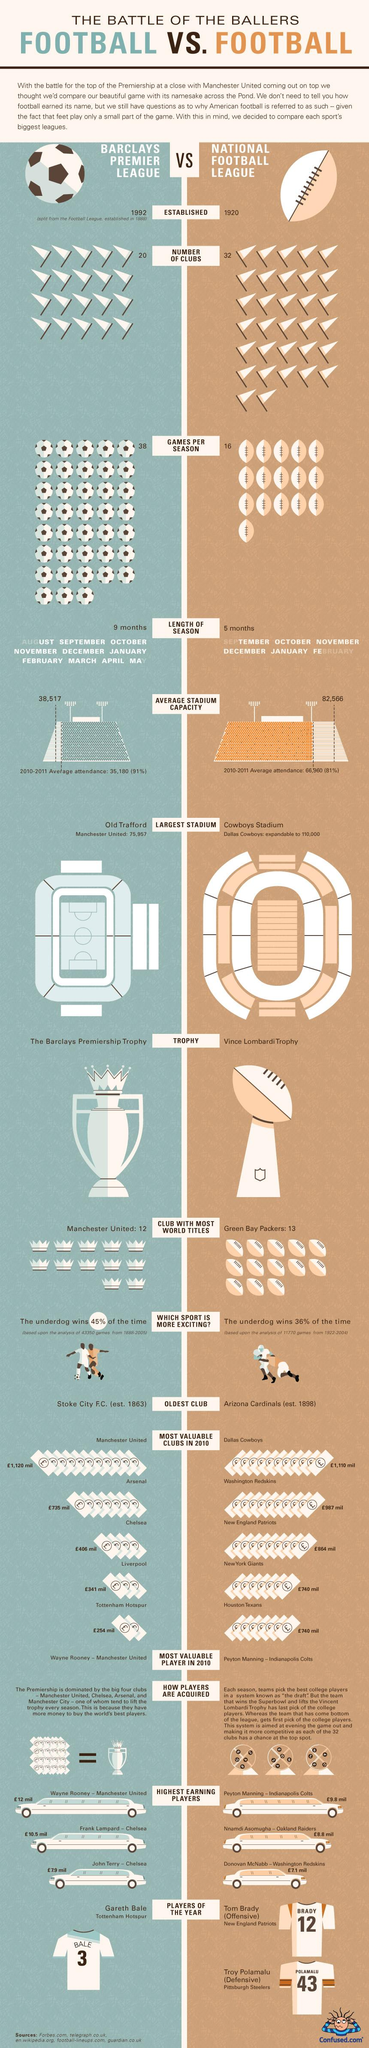Mention a couple of crucial points in this snapshot. Manchester United is the club that has won the most Barclays Premier League titles. The National Football League was established in 1920. The National Football League played 16 games per season on average. The Vince Lombardi Trophy is awarded to the winning team of the National Football League's championship game. There are currently 20 clubs participating in the Barclays Premier League. 